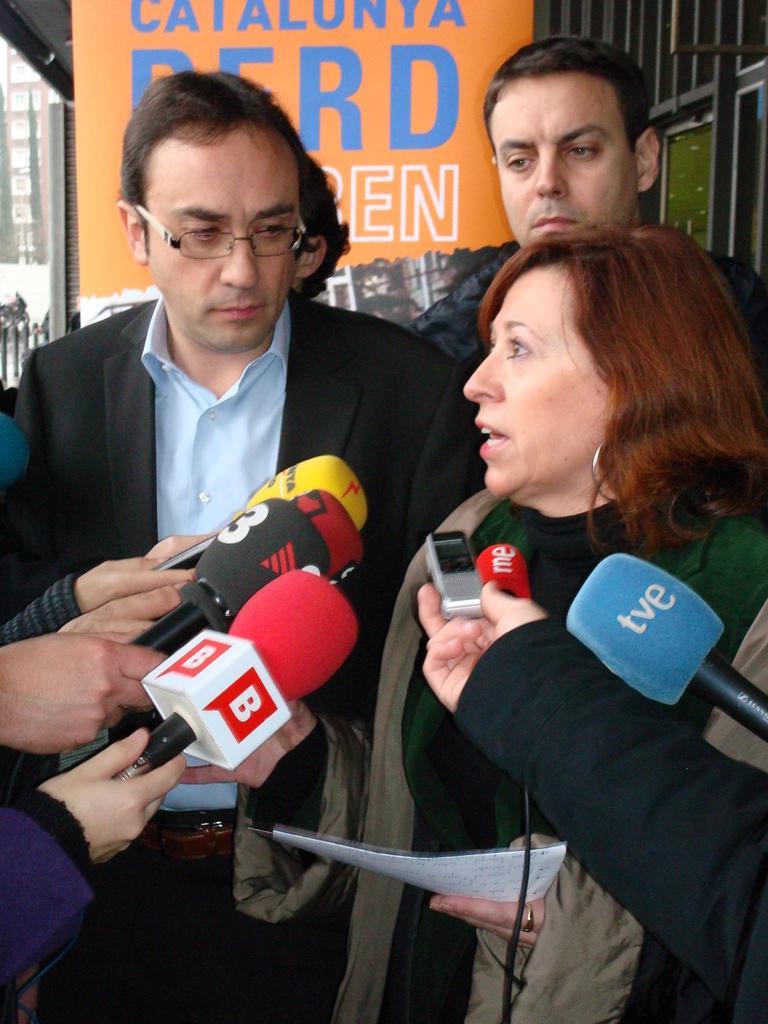How would you summarize this image in a sentence or two? This image is taken outdoors. In the background there are a few grills and a poster with a text on it. In the middle of the image three men and a woman are standing and a woman is holding a paper in her hand and a few people are holding mics in their hands. 